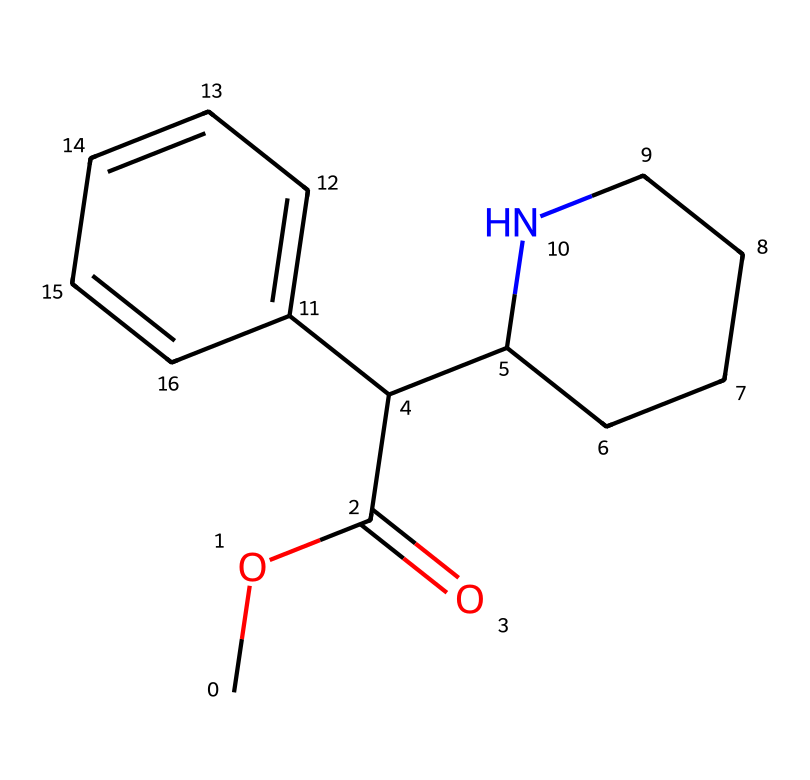How many carbon atoms are present in methylphenidate? In the SMILES representation, we count the 'C' symbols to determine the number of carbon atoms. The compound has several parts: the ester (COC(=O)), the central part (C(C1CCCCN1)), and the aromatic ring (C2=CC=CC=C2). After careful counting, there are 15 carbon atoms in total.
Answer: 15 What type of functional group is present in methylphenidate? The SMILES representation includes a 'COC(=O)' part, indicating the presence of an ester group due to the -COOR structure where 'R' represents another carbon chain. This is indicative of the chemical type shown in the structure.
Answer: ester How many nitrogen atoms are in the methylphenidate structure? In the SMILES, we look for 'N' symbols to identify the nitrogen atoms. There is one nitrogen atom in the cyclic part of the molecule (C1CCCCN1), indicating that it is a piperidine ring. Counting gives us one nitrogen atom.
Answer: 1 What is the consequence of the aromatic ring in the methylphenidate structure? The presence of the aromatic ring (C2=CC=CC=C2) adds stability to the molecule due to resonance, making the compound less reactive. This characteristic is significant in its biological activity, allowing for enhanced interaction with biological targets.
Answer: stability Is methylphenidate classified as an addictive substance? While methylphenidate is effective for treating ADHD, it has a potential for abuse due to its stimulant properties. This characteristic arises from how it interacts with neurotransmitter systems, particularly dopaminergic pathways. Thus, it is classified as a Schedule II controlled substance in the U.S.
Answer: yes 